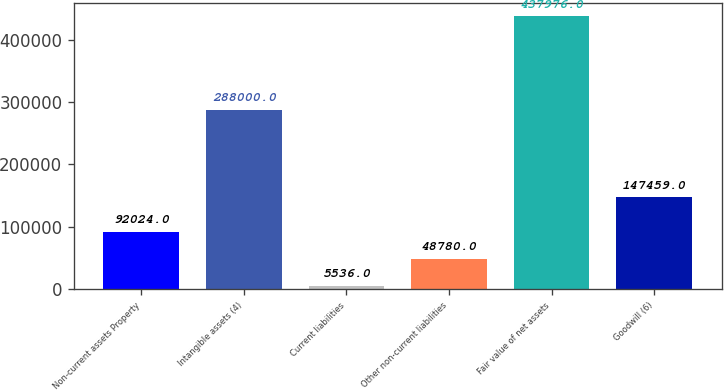Convert chart to OTSL. <chart><loc_0><loc_0><loc_500><loc_500><bar_chart><fcel>Non-current assets Property<fcel>Intangible assets (4)<fcel>Current liabilities<fcel>Other non-current liabilities<fcel>Fair value of net assets<fcel>Goodwill (6)<nl><fcel>92024<fcel>288000<fcel>5536<fcel>48780<fcel>437976<fcel>147459<nl></chart> 